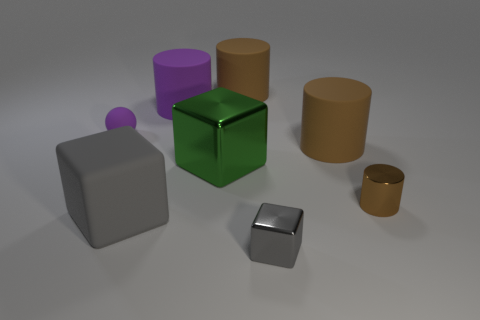Is the large purple thing the same shape as the brown metal object?
Provide a succinct answer. Yes. What is the color of the tiny object that is the same material as the large purple thing?
Keep it short and to the point. Purple. What number of objects are big brown cylinders that are in front of the big purple rubber thing or blocks?
Ensure brevity in your answer.  4. What size is the purple thing on the left side of the gray rubber thing?
Provide a succinct answer. Small. There is a ball; is its size the same as the metal thing on the left side of the tiny gray metallic block?
Your answer should be compact. No. The small metallic object to the left of the big brown matte object in front of the purple matte sphere is what color?
Your response must be concise. Gray. What number of other objects are the same color as the tiny metal cylinder?
Your answer should be very brief. 2. The ball is what size?
Offer a terse response. Small. Are there more gray matte blocks in front of the large green object than green cubes on the right side of the small brown cylinder?
Offer a terse response. Yes. What number of rubber objects are behind the tiny object that is behind the shiny cylinder?
Your answer should be very brief. 2. 